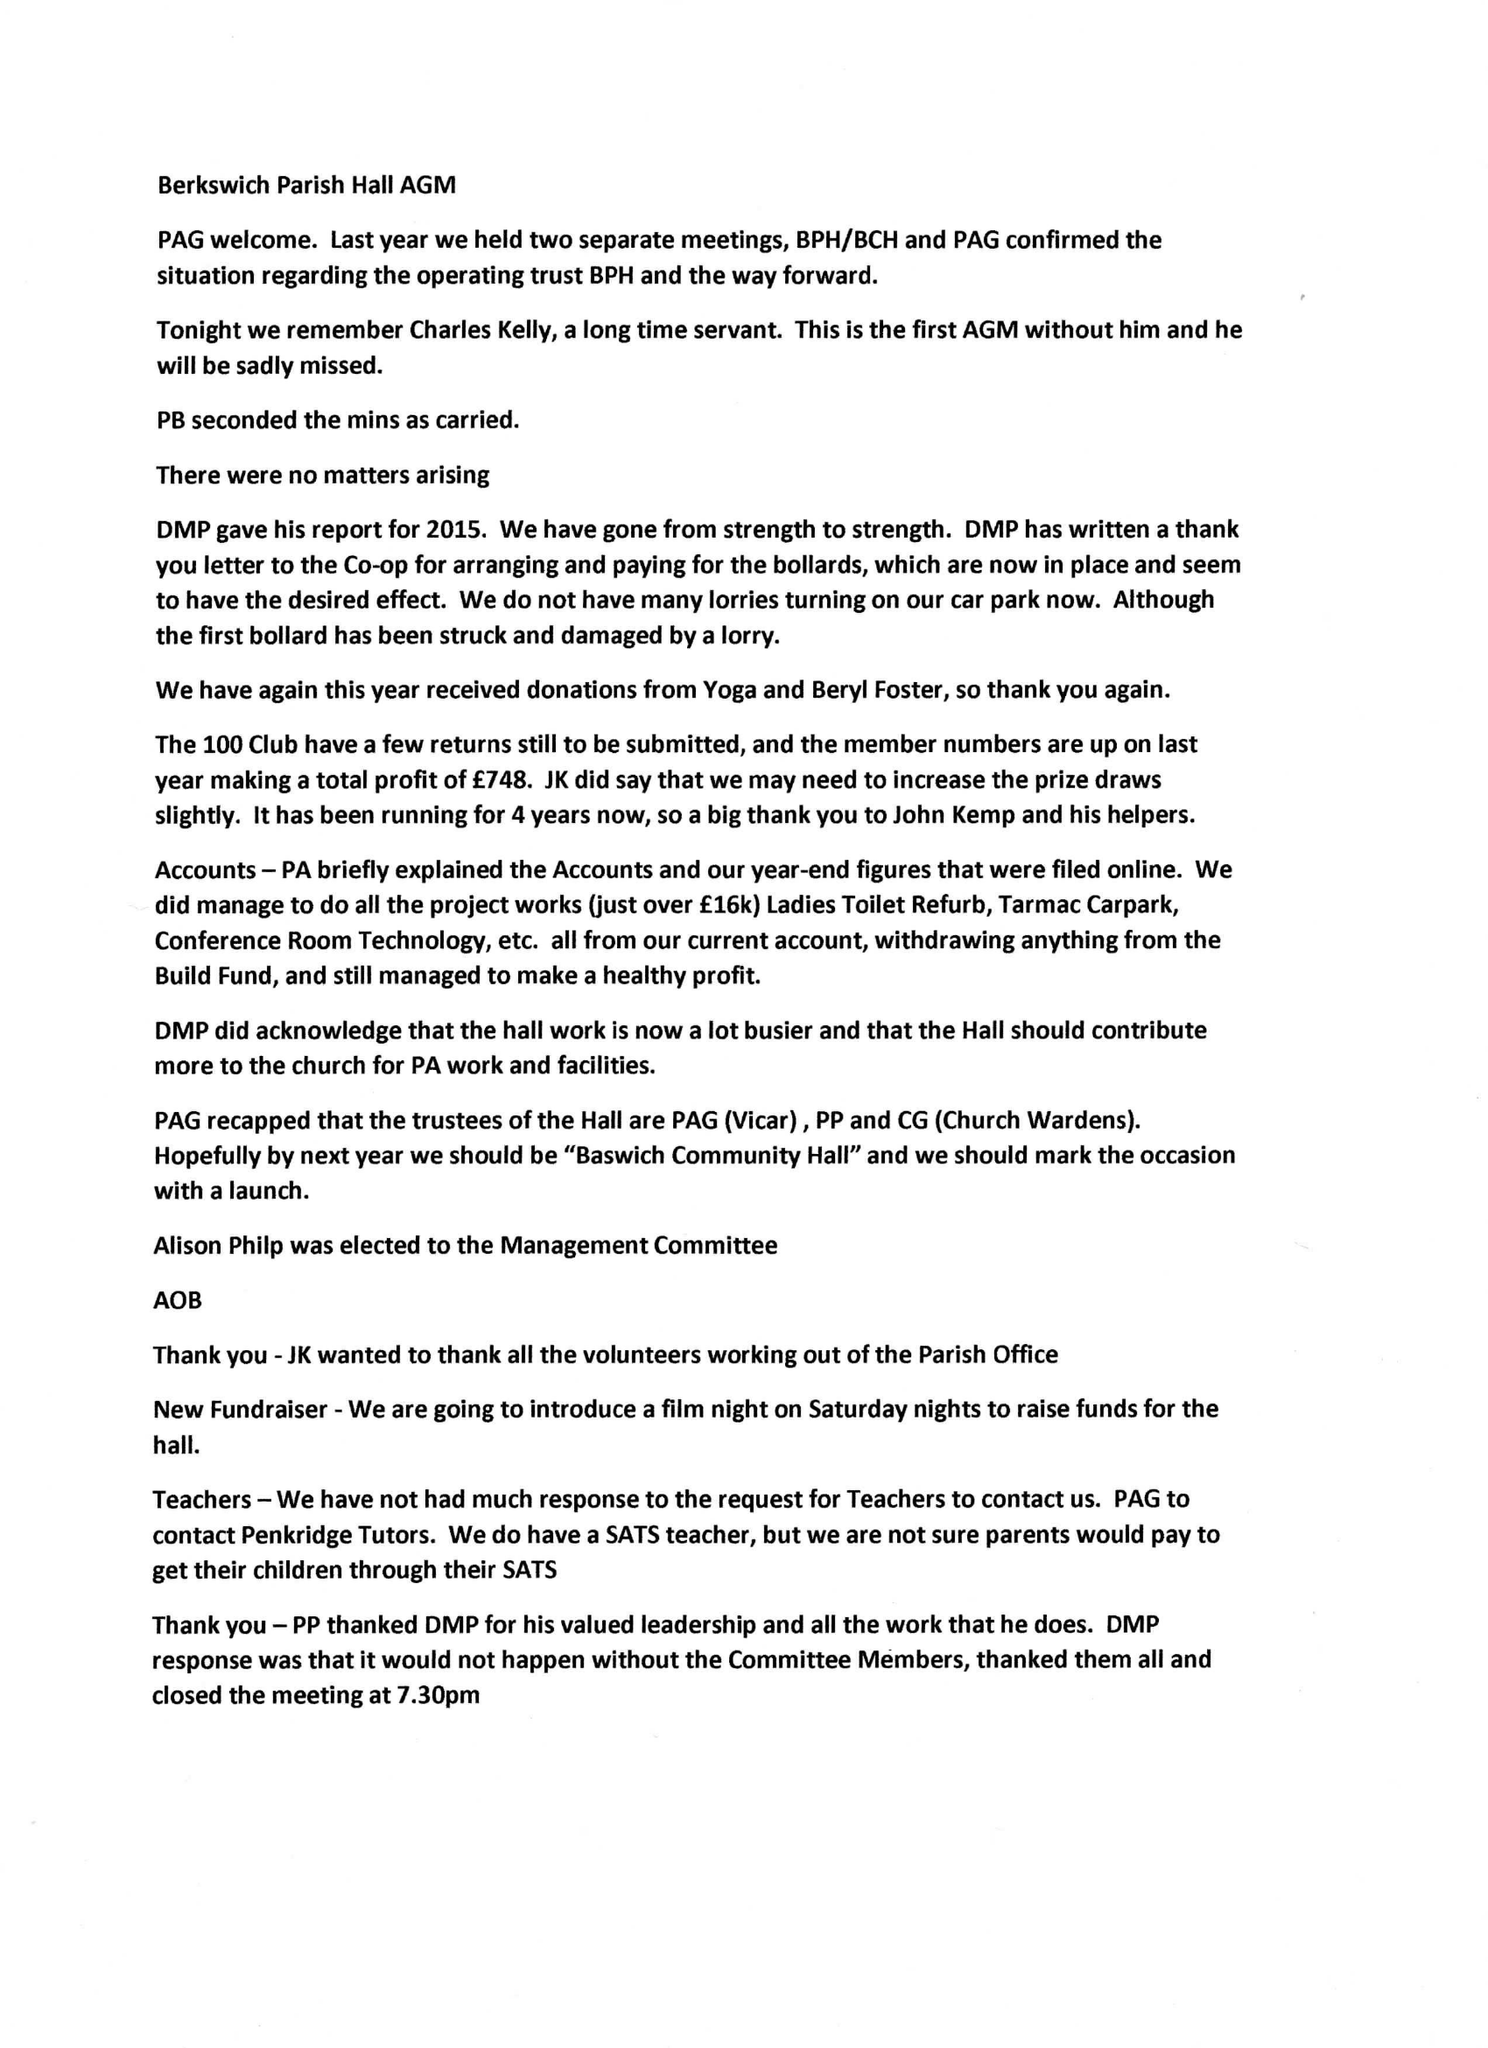What is the value for the address__postcode?
Answer the question using a single word or phrase. ST17 0BY 